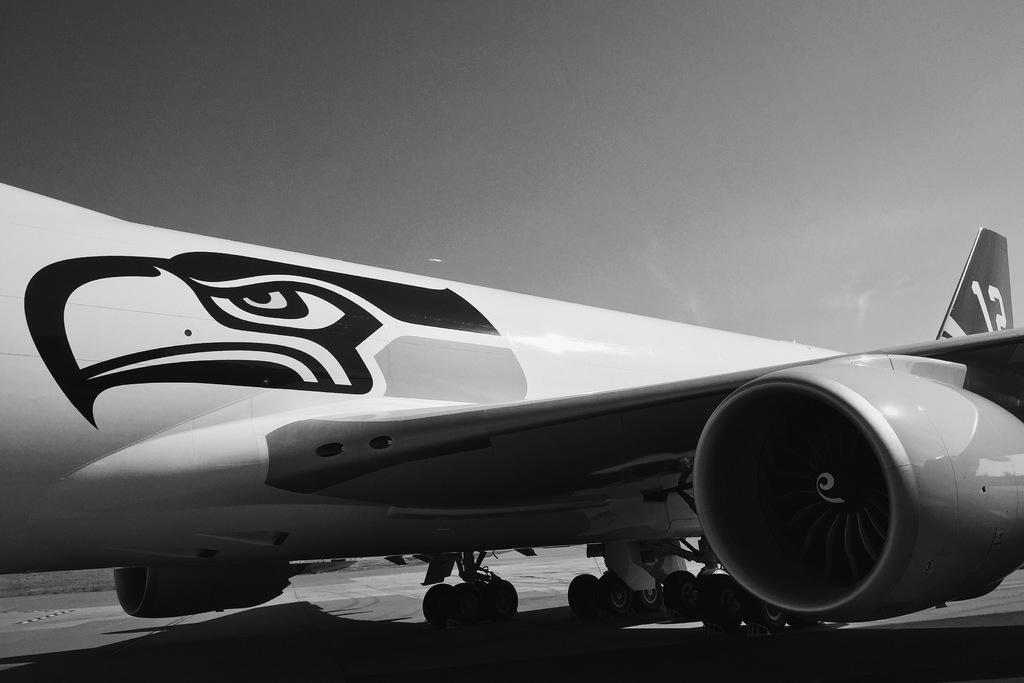What is the main subject of the image? The main subject of the image is an airplane. What else can be seen in the image besides the airplane? There is a logo and numbers written in the image. What is the color scheme of the image? The image is black and white in color. What type of wool is used to make the airplane in the image? There is no wool present in the image, as it features an airplane and other elements in a black and white color scheme. 